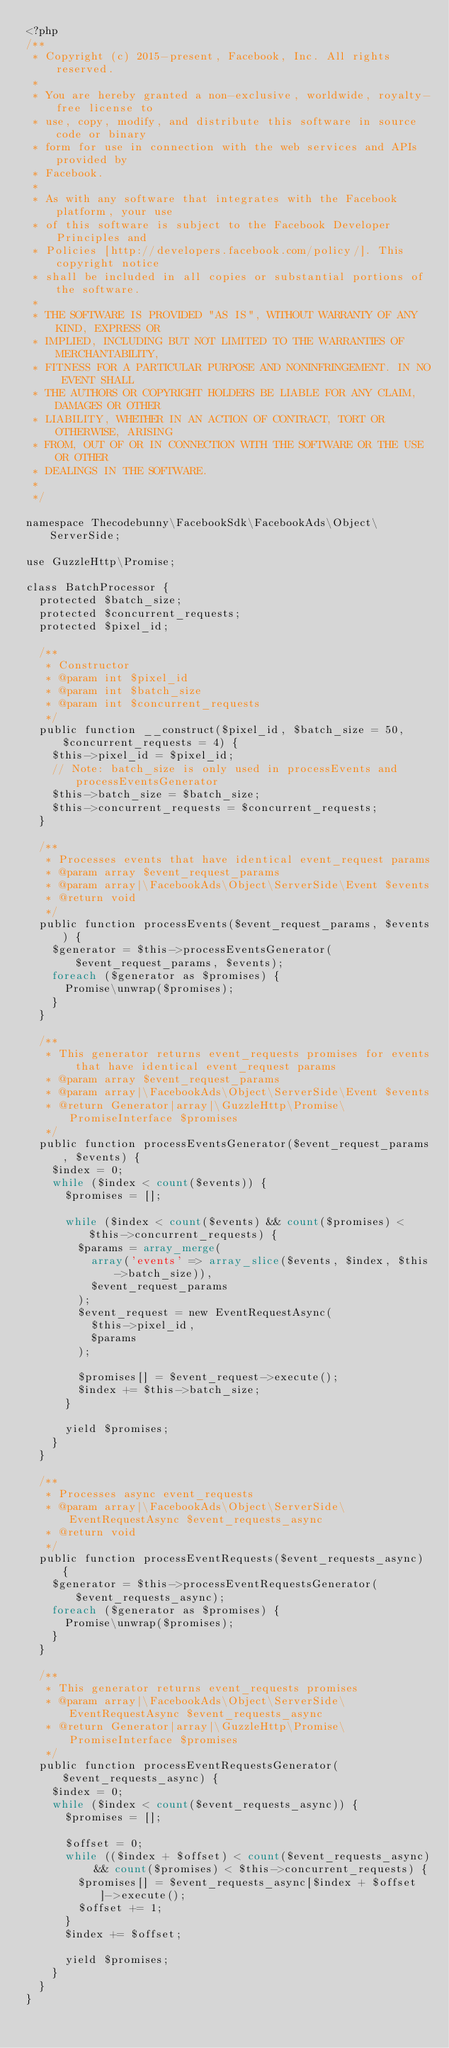Convert code to text. <code><loc_0><loc_0><loc_500><loc_500><_PHP_><?php
/**
 * Copyright (c) 2015-present, Facebook, Inc. All rights reserved.
 *
 * You are hereby granted a non-exclusive, worldwide, royalty-free license to
 * use, copy, modify, and distribute this software in source code or binary
 * form for use in connection with the web services and APIs provided by
 * Facebook.
 *
 * As with any software that integrates with the Facebook platform, your use
 * of this software is subject to the Facebook Developer Principles and
 * Policies [http://developers.facebook.com/policy/]. This copyright notice
 * shall be included in all copies or substantial portions of the software.
 *
 * THE SOFTWARE IS PROVIDED "AS IS", WITHOUT WARRANTY OF ANY KIND, EXPRESS OR
 * IMPLIED, INCLUDING BUT NOT LIMITED TO THE WARRANTIES OF MERCHANTABILITY,
 * FITNESS FOR A PARTICULAR PURPOSE AND NONINFRINGEMENT. IN NO EVENT SHALL
 * THE AUTHORS OR COPYRIGHT HOLDERS BE LIABLE FOR ANY CLAIM, DAMAGES OR OTHER
 * LIABILITY, WHETHER IN AN ACTION OF CONTRACT, TORT OR OTHERWISE, ARISING
 * FROM, OUT OF OR IN CONNECTION WITH THE SOFTWARE OR THE USE OR OTHER
 * DEALINGS IN THE SOFTWARE.
 *
 */

namespace Thecodebunny\FacebookSdk\FacebookAds\Object\ServerSide;

use GuzzleHttp\Promise;

class BatchProcessor {
  protected $batch_size;
  protected $concurrent_requests;
  protected $pixel_id;

  /**
   * Constructor
   * @param int $pixel_id
   * @param int $batch_size
   * @param int $concurrent_requests
   */
  public function __construct($pixel_id, $batch_size = 50, $concurrent_requests = 4) {
    $this->pixel_id = $pixel_id;
    // Note: batch_size is only used in processEvents and processEventsGenerator
    $this->batch_size = $batch_size;
    $this->concurrent_requests = $concurrent_requests;
  }

  /**
   * Processes events that have identical event_request params
   * @param array $event_request_params
   * @param array|\FacebookAds\Object\ServerSide\Event $events
   * @return void
   */
  public function processEvents($event_request_params, $events) {
    $generator = $this->processEventsGenerator($event_request_params, $events);
    foreach ($generator as $promises) {
      Promise\unwrap($promises);
    }
  }

  /**
   * This generator returns event_requests promises for events that have identical event_request params
   * @param array $event_request_params
   * @param array|\FacebookAds\Object\ServerSide\Event $events
   * @return Generator|array|\GuzzleHttp\Promise\PromiseInterface $promises
   */
  public function processEventsGenerator($event_request_params, $events) {
    $index = 0;
    while ($index < count($events)) {
      $promises = [];

      while ($index < count($events) && count($promises) < $this->concurrent_requests) {
        $params = array_merge(
          array('events' => array_slice($events, $index, $this->batch_size)),
          $event_request_params
        );
        $event_request = new EventRequestAsync(
          $this->pixel_id,
          $params
        );

        $promises[] = $event_request->execute();
        $index += $this->batch_size;
      }

      yield $promises;
    }
  }

  /**
   * Processes async event_requests
   * @param array|\FacebookAds\Object\ServerSide\EventRequestAsync $event_requests_async
   * @return void
   */
  public function processEventRequests($event_requests_async) {
    $generator = $this->processEventRequestsGenerator($event_requests_async);
    foreach ($generator as $promises) {
      Promise\unwrap($promises);
    }
  }

  /**
   * This generator returns event_requests promises
   * @param array|\FacebookAds\Object\ServerSide\EventRequestAsync $event_requests_async
   * @return Generator|array|\GuzzleHttp\Promise\PromiseInterface $promises
   */
  public function processEventRequestsGenerator($event_requests_async) {
    $index = 0;
    while ($index < count($event_requests_async)) {
      $promises = [];

      $offset = 0;
      while (($index + $offset) < count($event_requests_async) && count($promises) < $this->concurrent_requests) {
        $promises[] = $event_requests_async[$index + $offset]->execute();
        $offset += 1;
      }
      $index += $offset;

      yield $promises;
    }
  }
}
</code> 